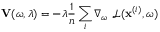<formula> <loc_0><loc_0><loc_500><loc_500>V ( \omega , \lambda ) = - \lambda \frac { 1 } { n } \sum _ { i } \nabla _ { \omega } \, \mathcal { L } ( x ^ { ( i ) } , \omega )</formula> 